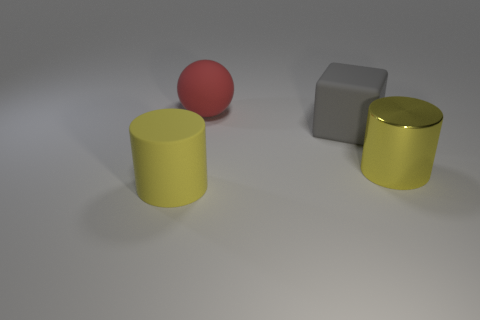Is there a large gray thing that is behind the cylinder on the left side of the red matte object that is behind the big yellow metallic cylinder?
Keep it short and to the point. Yes. What number of red things are there?
Keep it short and to the point. 1. How many things are big yellow cylinders that are in front of the metallic cylinder or large objects to the right of the big red thing?
Give a very brief answer. 3. Do the red rubber ball that is on the left side of the rubber cube and the yellow matte cylinder have the same size?
Your response must be concise. Yes. There is another thing that is the same shape as the metal object; what size is it?
Your answer should be very brief. Large. There is a ball that is the same size as the gray thing; what material is it?
Provide a succinct answer. Rubber. There is another big thing that is the same shape as the big shiny object; what is it made of?
Make the answer very short. Rubber. What number of other things are there of the same size as the shiny cylinder?
Give a very brief answer. 3. The rubber cylinder that is the same color as the big metal object is what size?
Provide a short and direct response. Large. How many large cylinders have the same color as the rubber cube?
Offer a terse response. 0. 